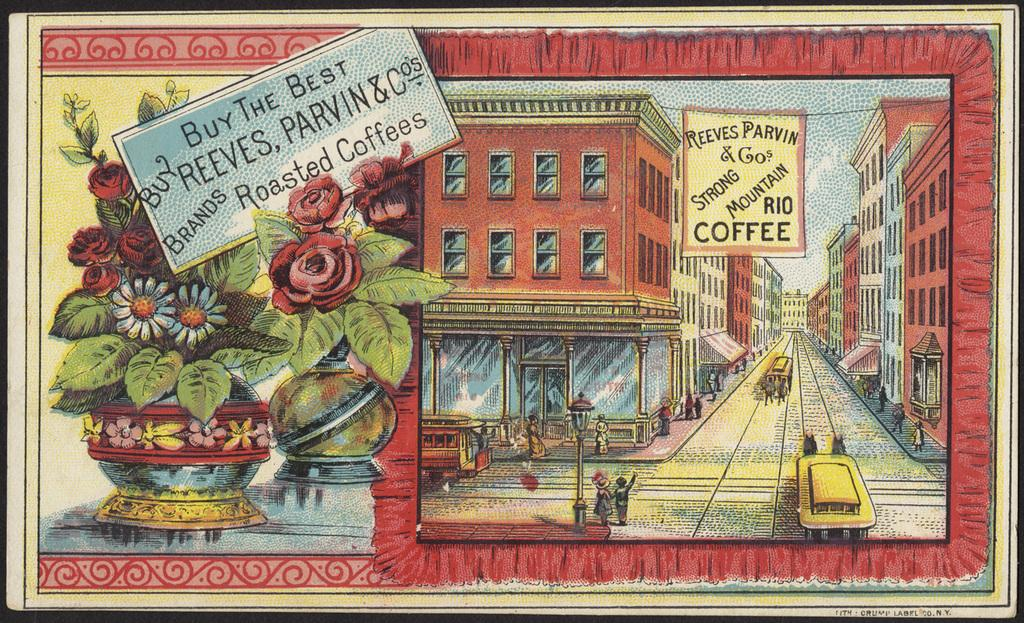<image>
Relay a brief, clear account of the picture shown. Vintage poster illustration for Reeves Parvin & Co. brands roasted coffee showing a town. 